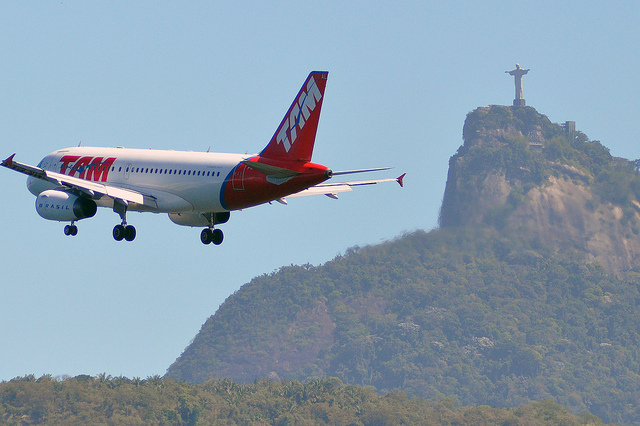What is the relative position of the airplane to the statue? The airplane is positioned in the foreground of the image, appearing closer to the viewer, while the Christ the Redeemer statue is situated in the background on top of a hill. The airplane seems to be flying towards the right, with the statue perched atop the hill behind it. 